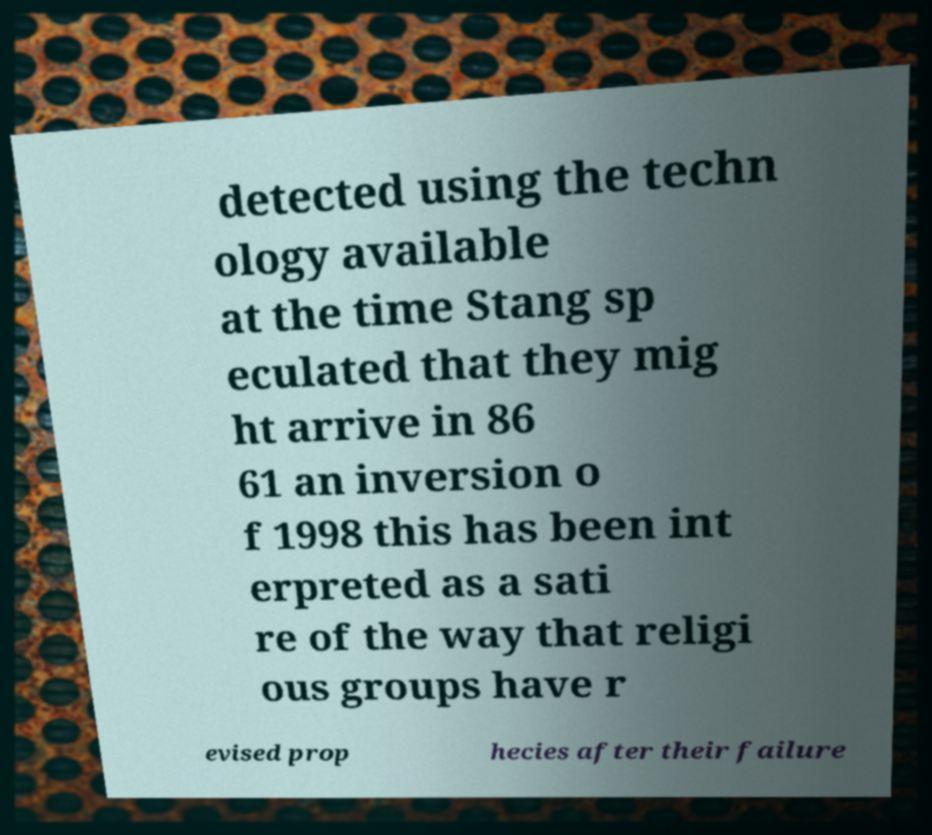There's text embedded in this image that I need extracted. Can you transcribe it verbatim? detected using the techn ology available at the time Stang sp eculated that they mig ht arrive in 86 61 an inversion o f 1998 this has been int erpreted as a sati re of the way that religi ous groups have r evised prop hecies after their failure 